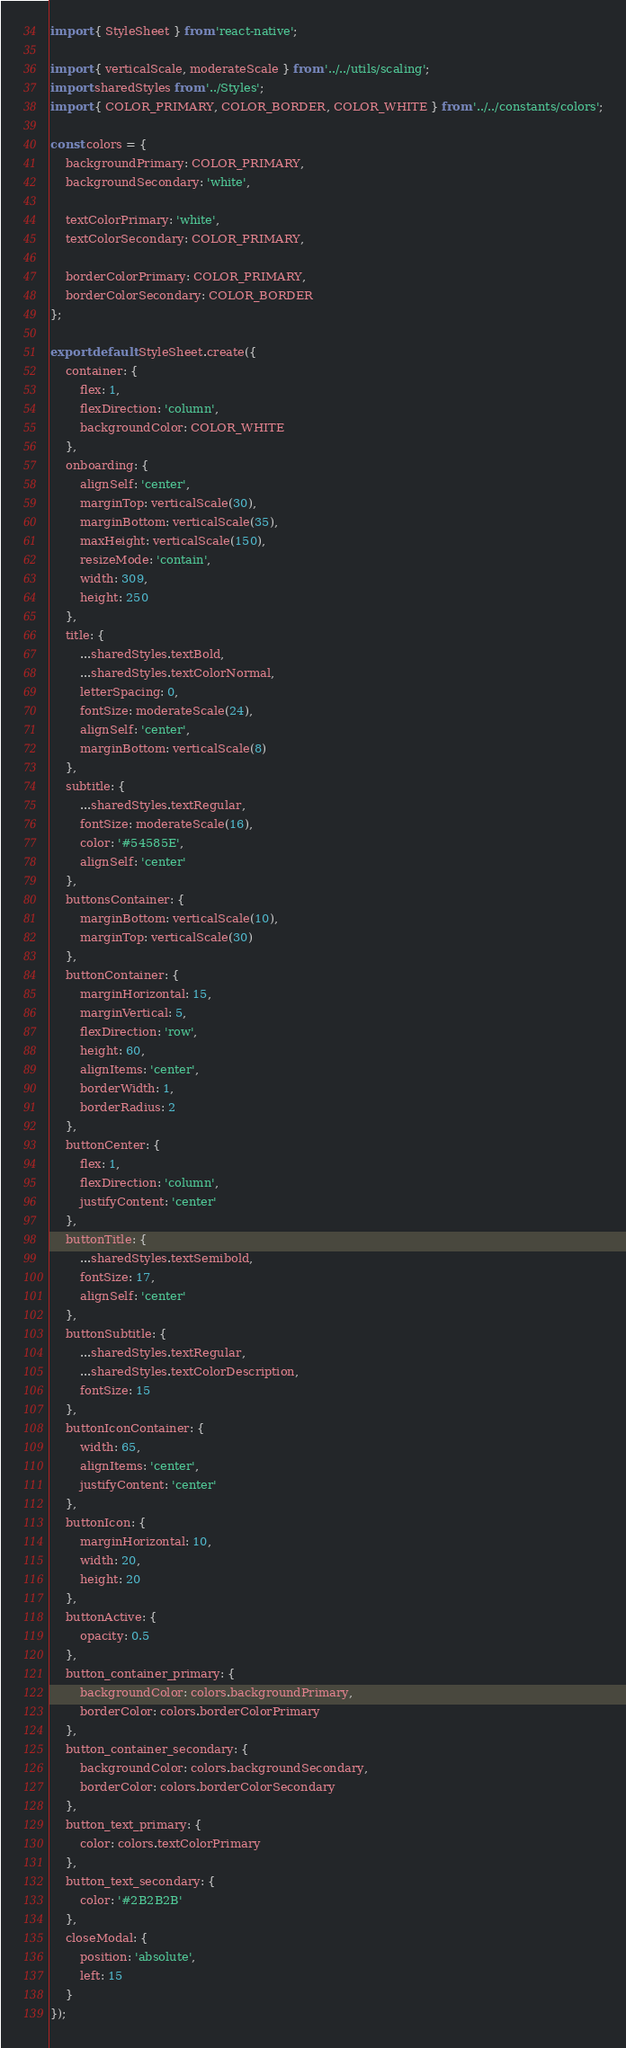Convert code to text. <code><loc_0><loc_0><loc_500><loc_500><_JavaScript_>import { StyleSheet } from 'react-native';

import { verticalScale, moderateScale } from '../../utils/scaling';
import sharedStyles from '../Styles';
import { COLOR_PRIMARY, COLOR_BORDER, COLOR_WHITE } from '../../constants/colors';

const colors = {
	backgroundPrimary: COLOR_PRIMARY,
	backgroundSecondary: 'white',

	textColorPrimary: 'white',
	textColorSecondary: COLOR_PRIMARY,

	borderColorPrimary: COLOR_PRIMARY,
	borderColorSecondary: COLOR_BORDER
};

export default StyleSheet.create({
	container: {
		flex: 1,
		flexDirection: 'column',
		backgroundColor: COLOR_WHITE
	},
	onboarding: {
		alignSelf: 'center',
		marginTop: verticalScale(30),
		marginBottom: verticalScale(35),
		maxHeight: verticalScale(150),
		resizeMode: 'contain',
		width: 309,
		height: 250
	},
	title: {
		...sharedStyles.textBold,
		...sharedStyles.textColorNormal,
		letterSpacing: 0,
		fontSize: moderateScale(24),
		alignSelf: 'center',
		marginBottom: verticalScale(8)
	},
	subtitle: {
		...sharedStyles.textRegular,
		fontSize: moderateScale(16),
		color: '#54585E',
		alignSelf: 'center'
	},
	buttonsContainer: {
		marginBottom: verticalScale(10),
		marginTop: verticalScale(30)
	},
	buttonContainer: {
		marginHorizontal: 15,
		marginVertical: 5,
		flexDirection: 'row',
		height: 60,
		alignItems: 'center',
		borderWidth: 1,
		borderRadius: 2
	},
	buttonCenter: {
		flex: 1,
		flexDirection: 'column',
		justifyContent: 'center'
	},
	buttonTitle: {
		...sharedStyles.textSemibold,
		fontSize: 17,
		alignSelf: 'center'
	},
	buttonSubtitle: {
		...sharedStyles.textRegular,
		...sharedStyles.textColorDescription,
		fontSize: 15
	},
	buttonIconContainer: {
		width: 65,
		alignItems: 'center',
		justifyContent: 'center'
	},
	buttonIcon: {
		marginHorizontal: 10,
		width: 20,
		height: 20
	},
	buttonActive: {
		opacity: 0.5
	},
	button_container_primary: {
		backgroundColor: colors.backgroundPrimary,
		borderColor: colors.borderColorPrimary
	},
	button_container_secondary: {
		backgroundColor: colors.backgroundSecondary,
		borderColor: colors.borderColorSecondary
	},
	button_text_primary: {
		color: colors.textColorPrimary
	},
	button_text_secondary: {
		color: '#2B2B2B'
	},
	closeModal: {
		position: 'absolute',
		left: 15
	}
});
</code> 